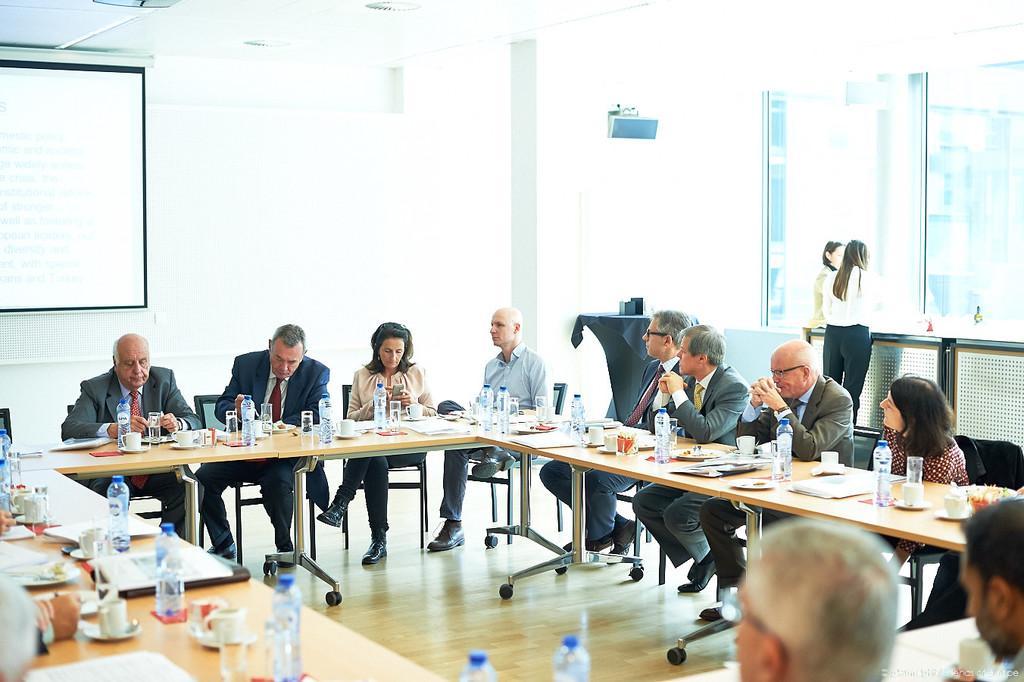In one or two sentences, can you explain what this image depicts? There is a group of people. There is a table. There is a bottle,cup ,saucer on a table. We can see the background there is a projector,window. 